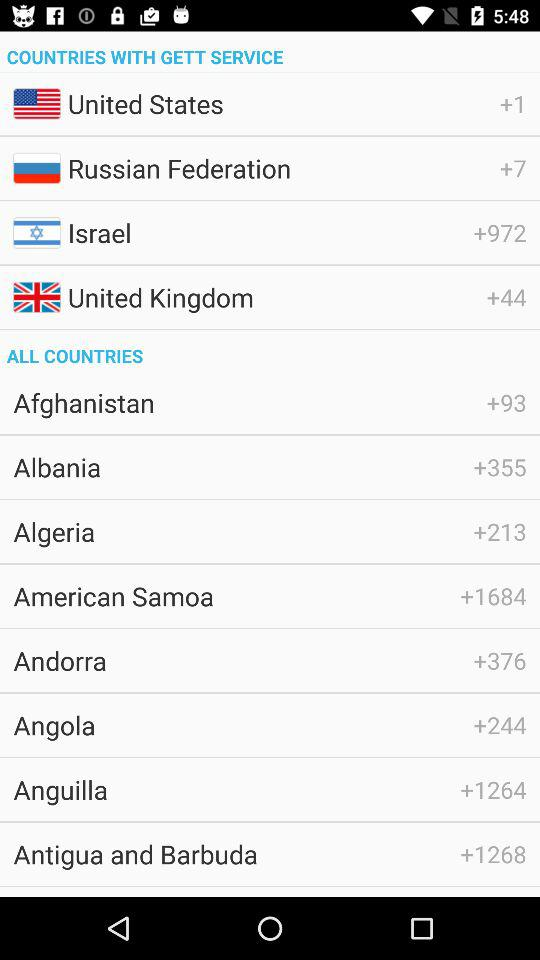What's the country code of Algeria? The country code of Algeria is +213. 